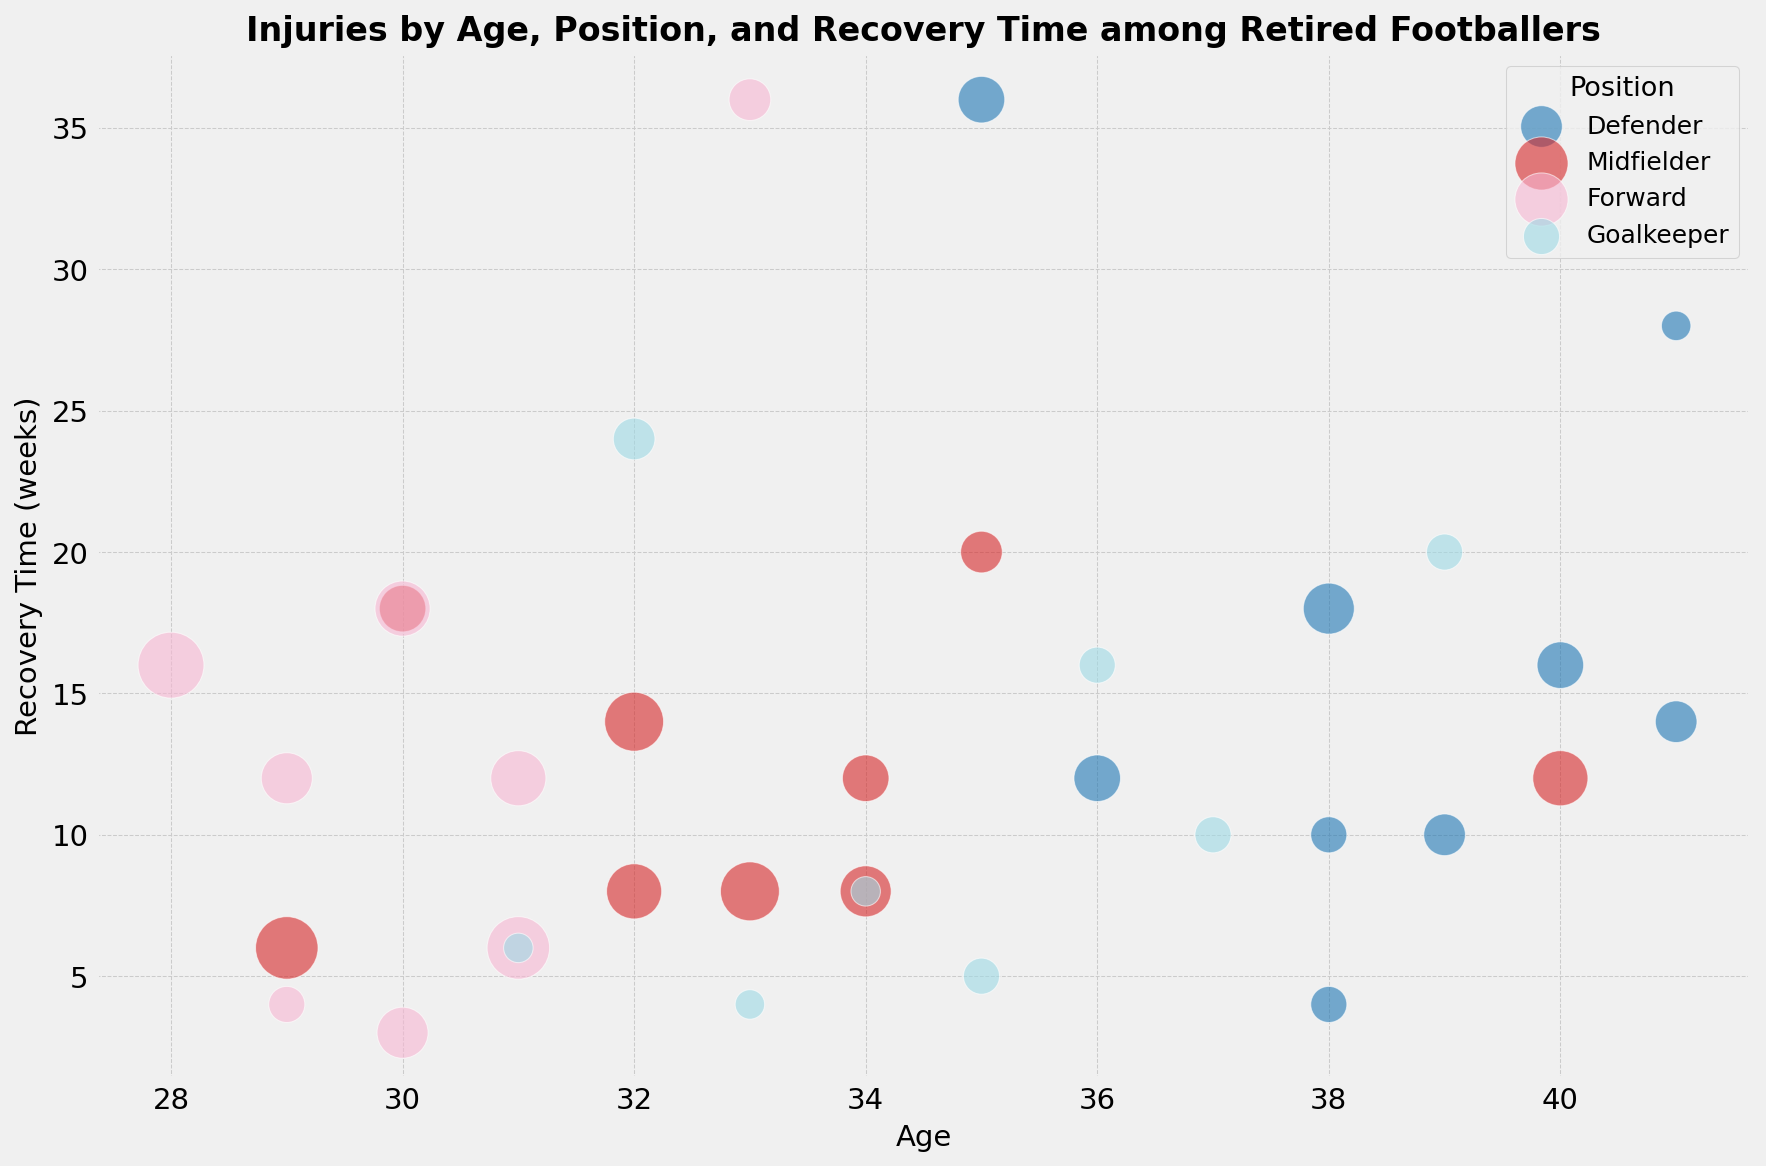What is the range of recovery times for ACL Tear injuries? By examining the bubble chart, identify the highest and lowest recovery times for bubbles representing ACL Tear injuries. The recovery times for ACL Tear injuries are 36 weeks (since there are two data points with this value). Therefore, the range is from 36 to 36.
Answer: 36 weeks Which position has the highest occurrence count for Ankle Sprain injuries, and what is the total occurrence count for this injury? For Ankle Sprain injuries, look at the bubbles color-coded by position. Midfielders and Forwards both show two data points each with occurrence counts (Midfielder: 9, Forward: 9). To find the total occurrence, sum these values: 9 + 9 = 18.
Answer: Midfielder, 18 What is the average recovery time for Groin Strain and Groin Tear injuries? Identify the recovery times for both injury types. Groin Strain (ages 33, 34): 8 weeks each. Groin Tear (age 38): 10 weeks. Calculate the average: (8 + 8 + 10) / 3 = 26/3 = ∼8.67 weeks.
Answer: ∼8.67 weeks Which position and age group combination has the longest recovery time for Hamstring Tear injuries? Examine the bubbles for Hamstring Tear injuries color-coded by position. The longest recovery time is 14 weeks, appearing at ages 32 (Midfielder) and 41 (Defender).
Answer: Midfielder, 32; Defender, 41 Are there more injuries with recovery times of 12 weeks or 16 weeks? Count the number of bubbles whose size represents occurrence counts at recovery times of 12 weeks and 16 weeks. There are more bubbles at 12 weeks (7 injuries) than at 16 weeks (5 injuries).
Answer: 12 weeks How does the occurrence count of Concussions compare between the Forward and Defender positions? Identify the bubbles representing concussions and their occurrence counts. Forward has one occurrence count of 3 (age 29), and Defender has two occurrence counts of 3 (ages 29 and 38).
Answer: Equal, 3 each What is the total occurrence count for injuries at age 35 and how do they differ across positions? Identify all bubbles at age 35. Defender: ACL Tear (5), Goalkeeper: Wrist Sprain (3), Midfielder: Ankle Fracture (4). Sum these values: 5 + 3 + 4 = 12.
Answer: 12, across Defender, Goalkeeper, Midfielder What is the average recovery time for injuries among Goalkeepers? Isolate the recovery times for all injuries marked by Goalkeeper: 24, 6, 5, 16, 8, 20, 10, 16, 4 weeks. Calculate the average: (24+6+5+16+8+20+10+16+4) / 9 = 109 / 9 = ∼12.11 weeks.
Answer: ∼12.11 weeks 